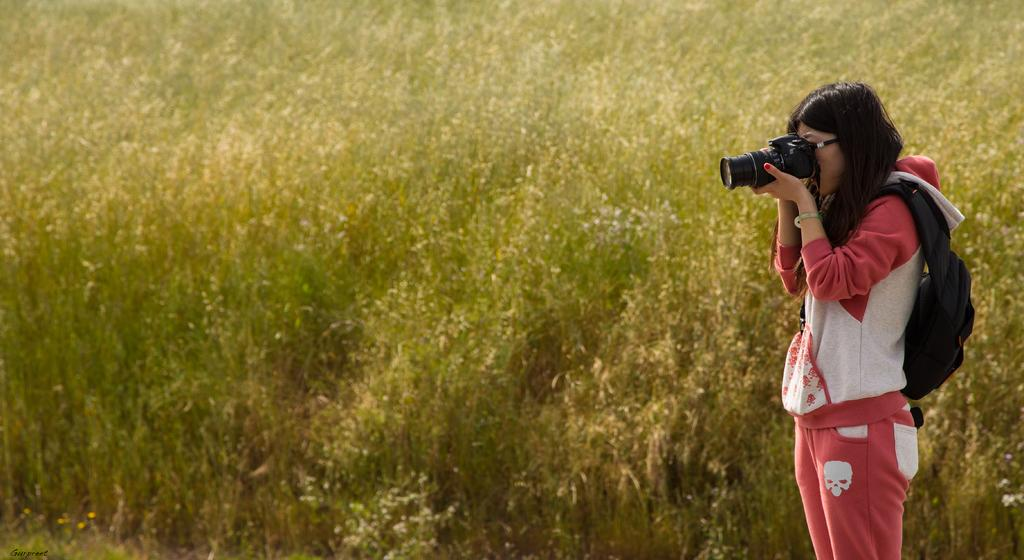Who is present in the image? There is a woman in the image. What is the woman wearing on her back? The woman is wearing a backpack. What is the woman holding in her hands? The woman is holding a camera. What type of environment can be seen in the image? There is greenery visible in the image. What type of book can be seen on the calculator in the image? There is no book or calculator present in the image. 